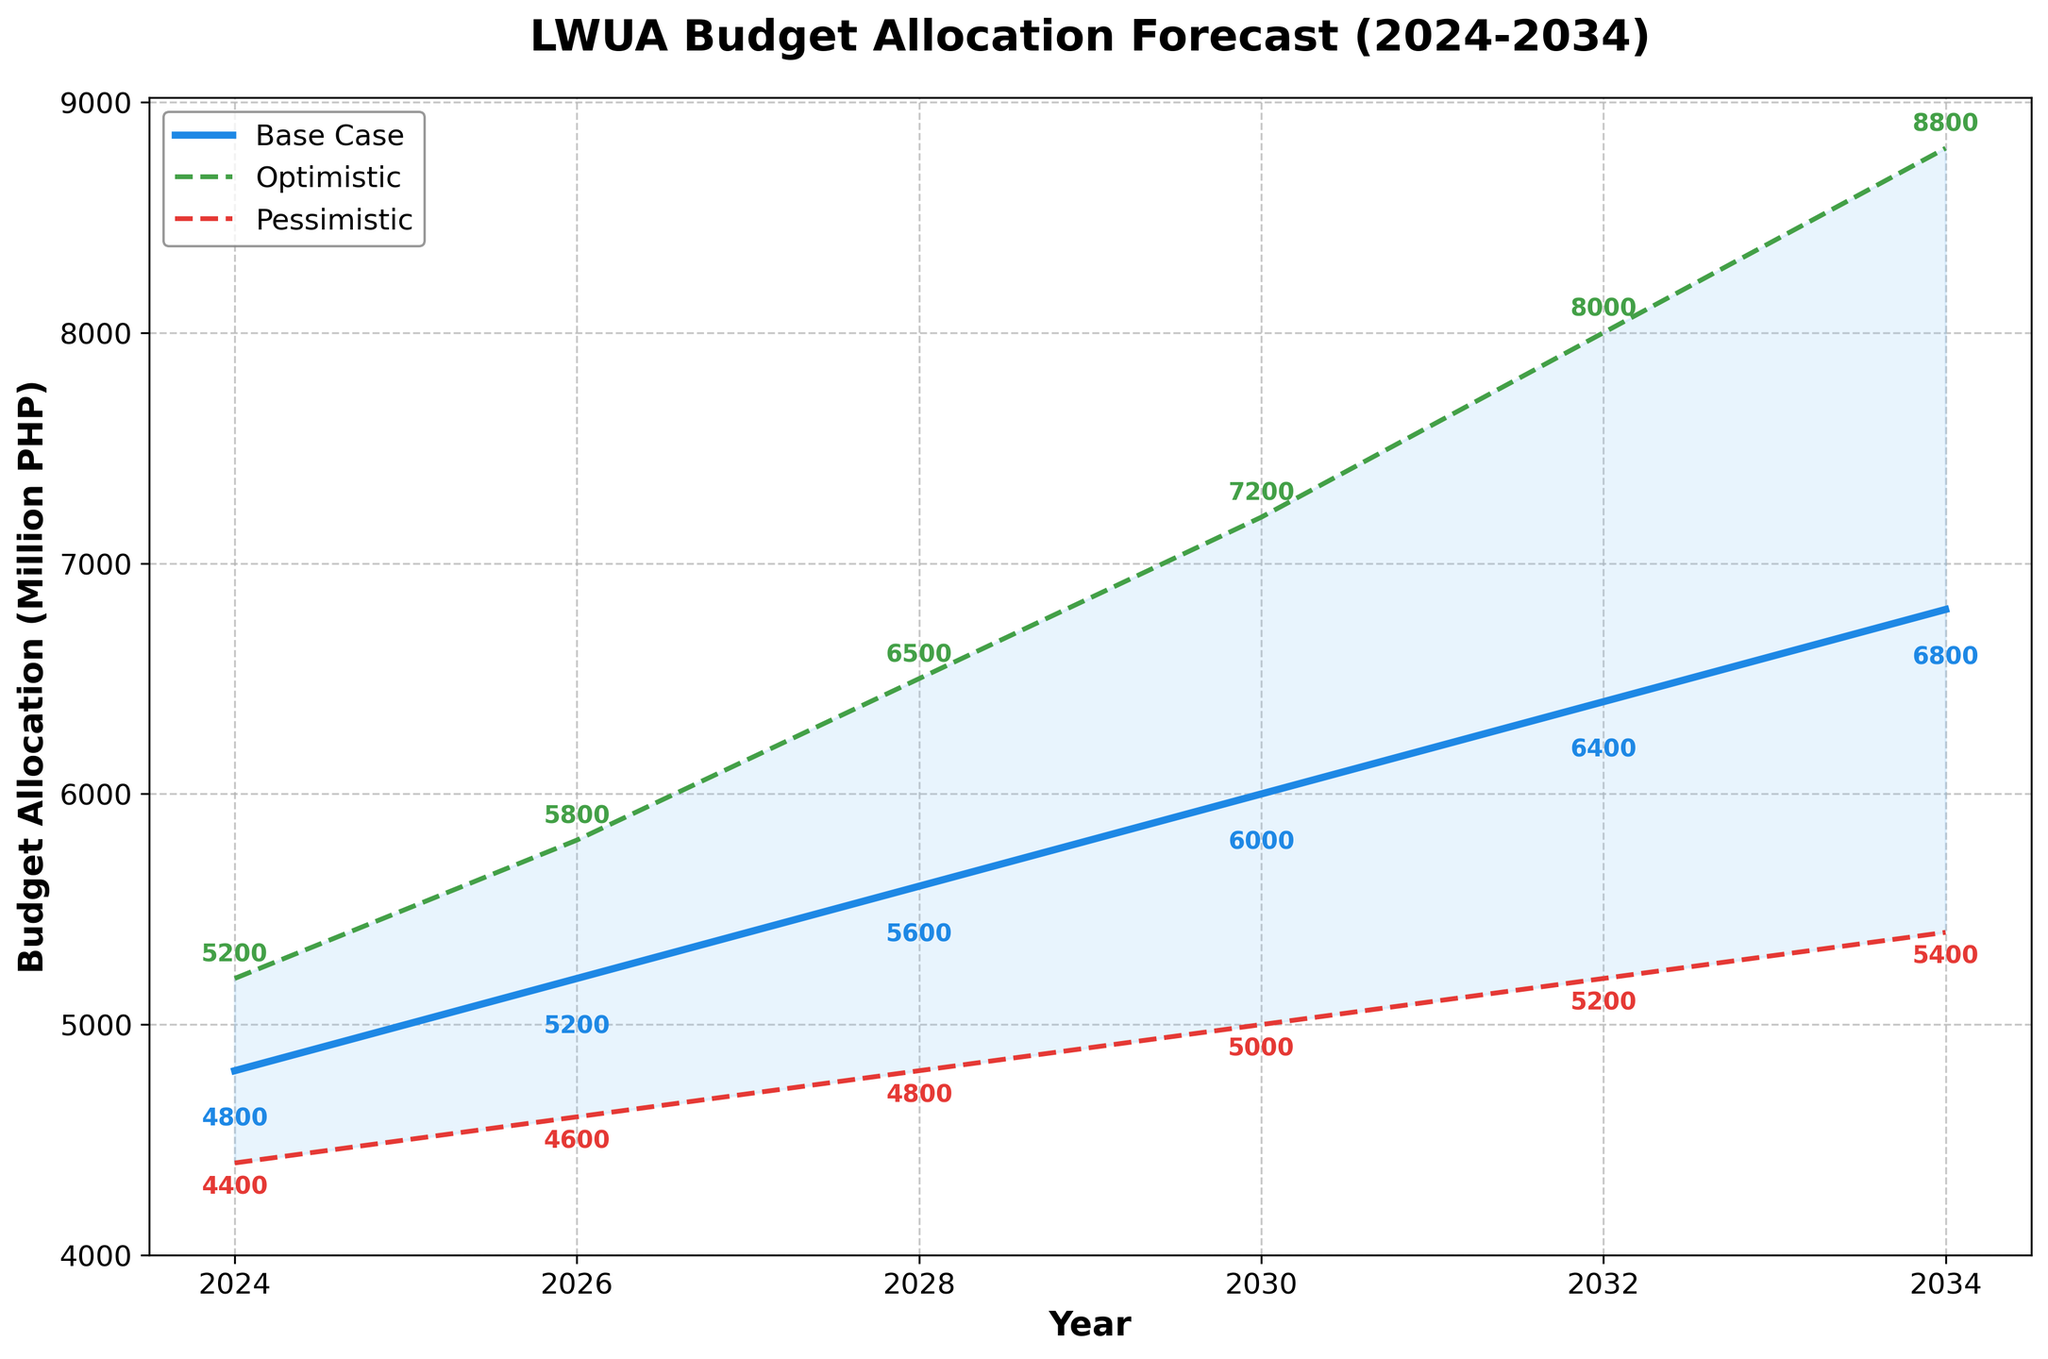What is the title of the plot? The title is typically displayed at the top of the plot and summarizes the main subject of the chart. In this case, the title reads "LWUA Budget Allocation Forecast (2024-2034)".
Answer: LWUA Budget Allocation Forecast (2024-2034) What is the budget allocation in 2028 for the optimistic scenario? Locate the year 2028 on the x-axis, then follow upwards to find the optimistic scenario, which is indicated by the green dashed line. The budget allocation value is labeled next to the line.
Answer: 6500 Million PHP How does the base case scenario budget change from 2024 to 2034? Find the base case values for 2024 and 2034 on the y-axis. The value for 2024 is 4800 and for 2034 is 6800. Subtract the two to find the change. 6800 - 4800 = 2000 Million PHP increase.
Answer: 2000 Million PHP increase What is the difference in budget allocation between the optimistic and pessimistic scenarios in 2034? Locate the values for both the optimistic (8800) and pessimistic (5400) scenarios for the year 2034. Subtract the pessimistic value from the optimistic value: 8800 - 5400 = 3400 Million PHP.
Answer: 3400 Million PHP Which year shows the greatest difference between the optimistic and pessimistic budget allocations? Calculate the difference between the optimistic and pessimistic scenarios for each year provided in the data, then identify the year with the largest difference. The differences are: 800 (2024), 1200 (2026), 1700 (2028), 2200 (2030), 2800 (2032), 3400 (2034). The largest difference is 3400 in 2034.
Answer: 2034 Does the base case scenario show an overall increasing or decreasing trend in the budget allocation? Observe the base case values for all years (2024-2034). The values are continuously increasing: 4800, 5200, 5600, 6000, 6400, 6800, indicating an overall increasing trend.
Answer: Increasing What range of budget allocations is represented by the shaded region in 2032? The shaded region represents the range between the pessimistic and optimistic scenarios. For 2032, the values are 5200 (pessimistic) and 8000 (optimistic). The range is therefore from 5200 to 8000 Million PHP.
Answer: 5200 to 8000 Million PHP What is the average budget allocation in 2030 across all scenarios? Add the budget allocations for all three scenarios in 2030 and divide by the number of scenarios. (7200 + 6000 + 5000) / 3 = 18200 / 3 = 6066.67 Million PHP.
Answer: 6066.67 Million PHP Are there any years where the optimistic scenario does not see an increase compared to the previous forecast year? Compare the optimistic values for all consecutive forecast years. The values increase continuously: 5200 (2024), 5800 (2026), 6500 (2028), 7200 (2030), 8000 (2032), 8800 (2034). Thus, there is no year where the optimistic scenario does not increase compared to the previous forecast year.
Answer: No Which scenario reaches 6000 Million PHP first, and in what year? Identify the first year when each scenario reaches a budget of 6000 Million PHP or more. The base case is 2030, the optimistic is 2028, and the pessimistic never reaches 6000 Million PHP. Therefore, the optimistic scenario reaches it first in 2028.
Answer: Optimistic, 2028 